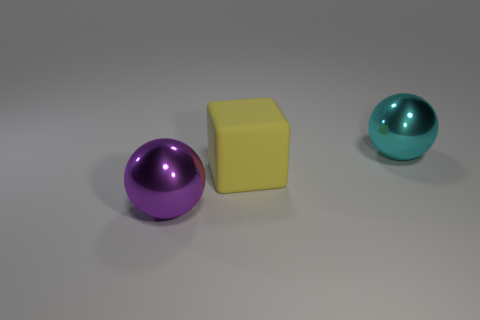What number of spheres are either big purple objects or big things?
Your answer should be compact. 2. There is another sphere that is the same size as the purple metal sphere; what color is it?
Offer a very short reply. Cyan. What is the shape of the shiny thing that is in front of the big thing behind the large cube?
Your answer should be very brief. Sphere. What number of other objects are the same material as the yellow thing?
Give a very brief answer. 0. How many purple objects are big metal things or large things?
Keep it short and to the point. 1. What number of metallic objects are on the right side of the large purple sphere?
Make the answer very short. 1. There is a shiny thing that is behind the block behind the ball that is left of the big cyan metal sphere; how big is it?
Provide a succinct answer. Large. There is a big sphere that is left of the big metal thing to the right of the yellow matte object; are there any big metal objects that are behind it?
Your answer should be compact. Yes. Are there more big purple objects than big purple rubber cubes?
Your answer should be compact. Yes. The large metal object in front of the yellow rubber block is what color?
Ensure brevity in your answer.  Purple. 